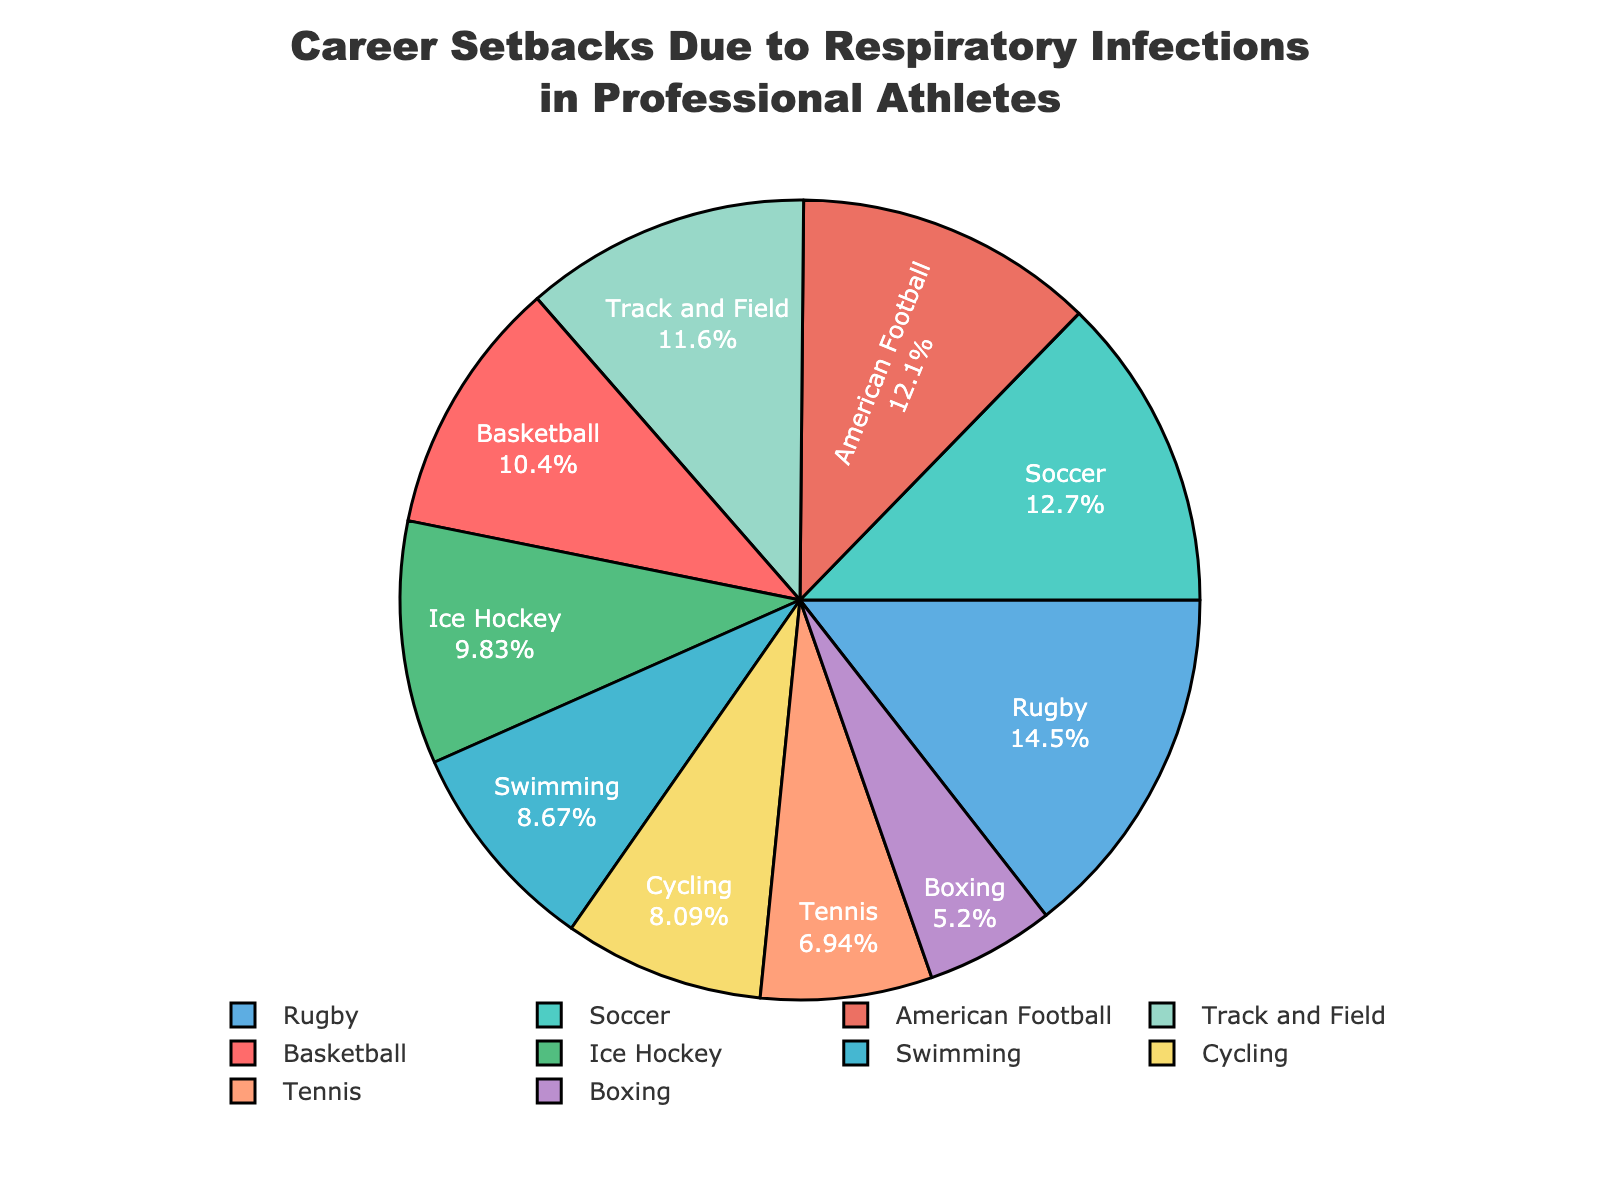What is the sport with the highest percentage of athletes experiencing career setbacks due to respiratory infections? Rugby has the highest percentage of athletes experiencing career setbacks at 25%, as shown by the largest section of the pie chart.
Answer: Rugby Which sport has a higher percentage of career setbacks due to respiratory infections: Basketball or Tennis? Basketball has an 18% share, and Tennis has a 12% share, so Basketball has a higher percentage.
Answer: Basketball What is the total percentage of athletes from Soccer and Track and Field who experienced career setbacks due to respiratory infections? The percentage of Soccer is 22% and Track and Field is 20%. Adding these two values, 22% + 20% = 42%.
Answer: 42% Which sport has a smaller portion of athletes experiencing career setbacks, Boxing or American Football? Boxing has a 9% share, while American Football has a 21% share. Thus, Boxing has a smaller portion.
Answer: Boxing How many sports have a percentage of athletes experiencing career setbacks equal to or greater than the average percentage? First compute the average percentage: (18 + 22 + 15 + 12 + 20 + 14 + 9 + 25 + 21 + 17) / 10 = 17.3%. The sports meeting this criterion are Soccer (22%), Track and Field (20%), Rugby (25%), and American Football (21%), totaling 4 sports.
Answer: 4 Which segment of the pie chart is green, and what percentage does it represent? The green segment represents Soccer, which accounts for 22% of the athletes experiencing career setbacks.
Answer: Soccer, 22% Are there more athletes experiencing career setbacks in Ice Hockey or Cycling? Ice Hockey represents 17%, Cycling represents 14%. Therefore, more athletes in Ice Hockey experience career setbacks.
Answer: Ice Hockey What is the difference in the percentage between the sport with the highest setbacks and the sport with the lowest setbacks? The highest percentage is 25% (Rugby), and the lowest is 9% (Boxing). The difference is 25% - 9% = 16%.
Answer: 16% What is the combined percentage of athletes in non-contact sports (Swimming, Tennis, Track and Field, Cycling)? The percentages are Swimming (15%), Tennis (12%), Track and Field (20%), Cycling (14%). Adding these values: 15% + 12% + 20% + 14% = 61%.
Answer: 61% Which color represents the sport of Basketball, and what is the value of its percentage share? The color red represents Basketball, and the percentage share is 18%.
Answer: Red, 18% 